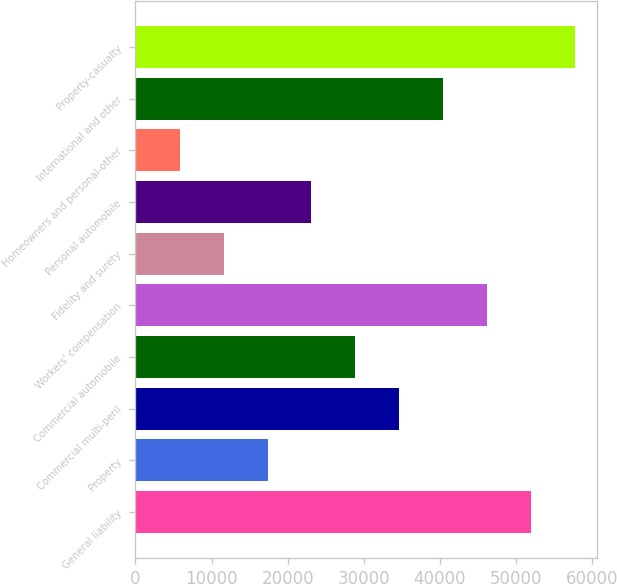Convert chart. <chart><loc_0><loc_0><loc_500><loc_500><bar_chart><fcel>General liability<fcel>Property<fcel>Commercial multi-peril<fcel>Commercial automobile<fcel>Workers' compensation<fcel>Fidelity and surety<fcel>Personal automobile<fcel>Homeowners and personal-other<fcel>International and other<fcel>Property-casualty<nl><fcel>51938.1<fcel>17366.7<fcel>34652.4<fcel>28890.5<fcel>46176.2<fcel>11604.8<fcel>23128.6<fcel>5842.9<fcel>40414.3<fcel>57700<nl></chart> 